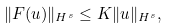Convert formula to latex. <formula><loc_0><loc_0><loc_500><loc_500>\| F ( u ) \| _ { H ^ { s } } \leq K \| u \| _ { H ^ { s } } ,</formula> 